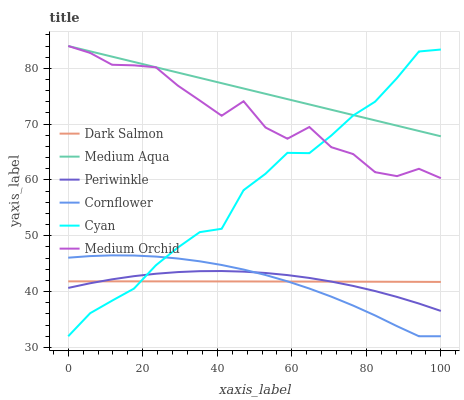Does Cornflower have the minimum area under the curve?
Answer yes or no. Yes. Does Medium Aqua have the maximum area under the curve?
Answer yes or no. Yes. Does Medium Orchid have the minimum area under the curve?
Answer yes or no. No. Does Medium Orchid have the maximum area under the curve?
Answer yes or no. No. Is Medium Aqua the smoothest?
Answer yes or no. Yes. Is Medium Orchid the roughest?
Answer yes or no. Yes. Is Cornflower the smoothest?
Answer yes or no. No. Is Cornflower the roughest?
Answer yes or no. No. Does Medium Orchid have the lowest value?
Answer yes or no. No. Does Medium Orchid have the highest value?
Answer yes or no. Yes. Does Cornflower have the highest value?
Answer yes or no. No. Is Periwinkle less than Medium Orchid?
Answer yes or no. Yes. Is Medium Orchid greater than Cornflower?
Answer yes or no. Yes. Does Cyan intersect Medium Aqua?
Answer yes or no. Yes. Is Cyan less than Medium Aqua?
Answer yes or no. No. Is Cyan greater than Medium Aqua?
Answer yes or no. No. Does Periwinkle intersect Medium Orchid?
Answer yes or no. No. 